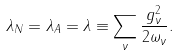<formula> <loc_0><loc_0><loc_500><loc_500>\lambda _ { N } = \lambda _ { A } = \lambda \equiv \sum _ { \nu } \frac { g ^ { 2 } _ { \nu } } { 2 \omega _ { \nu } } .</formula> 